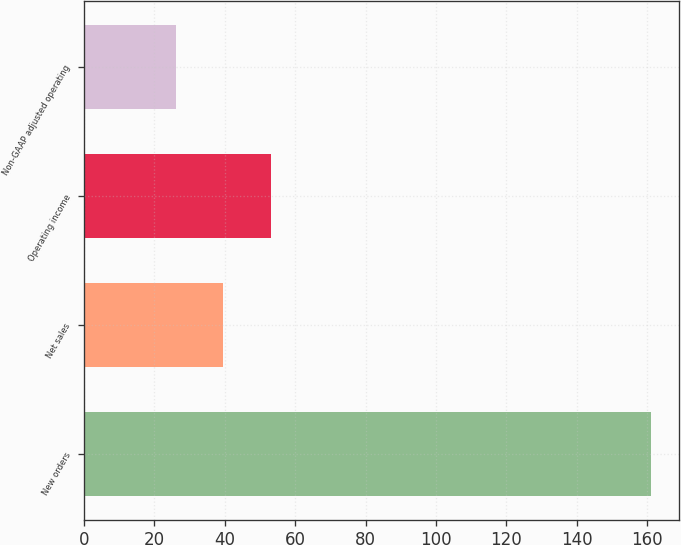Convert chart to OTSL. <chart><loc_0><loc_0><loc_500><loc_500><bar_chart><fcel>New orders<fcel>Net sales<fcel>Operating income<fcel>Non-GAAP adjusted operating<nl><fcel>161<fcel>39.5<fcel>53<fcel>26<nl></chart> 